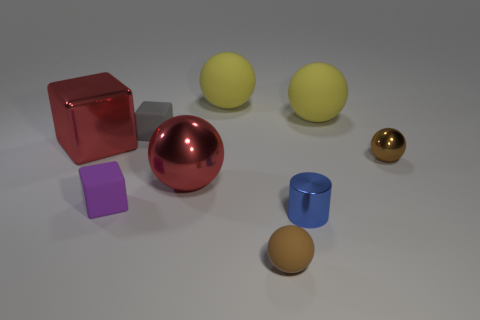How might the colors of these objects affect one's perception of their size? Different colors can create optical illusions affecting perception of size. For instance, darker objects may seem smaller compared to lighter colored objects of the same size. However, in this image, size perception is likely influenced more by the actual sizes and distances of the objects relative to each other. 